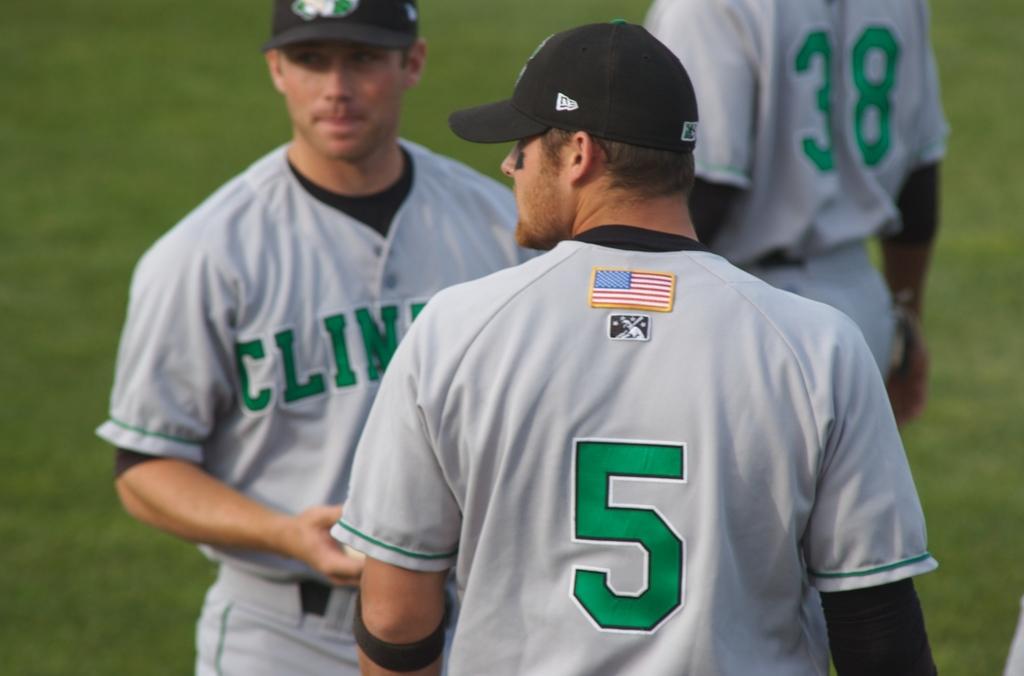What is the large green number on the back of the closest player?
Offer a terse response. 5. What is the number of the player in the background?
Ensure brevity in your answer.  38. 